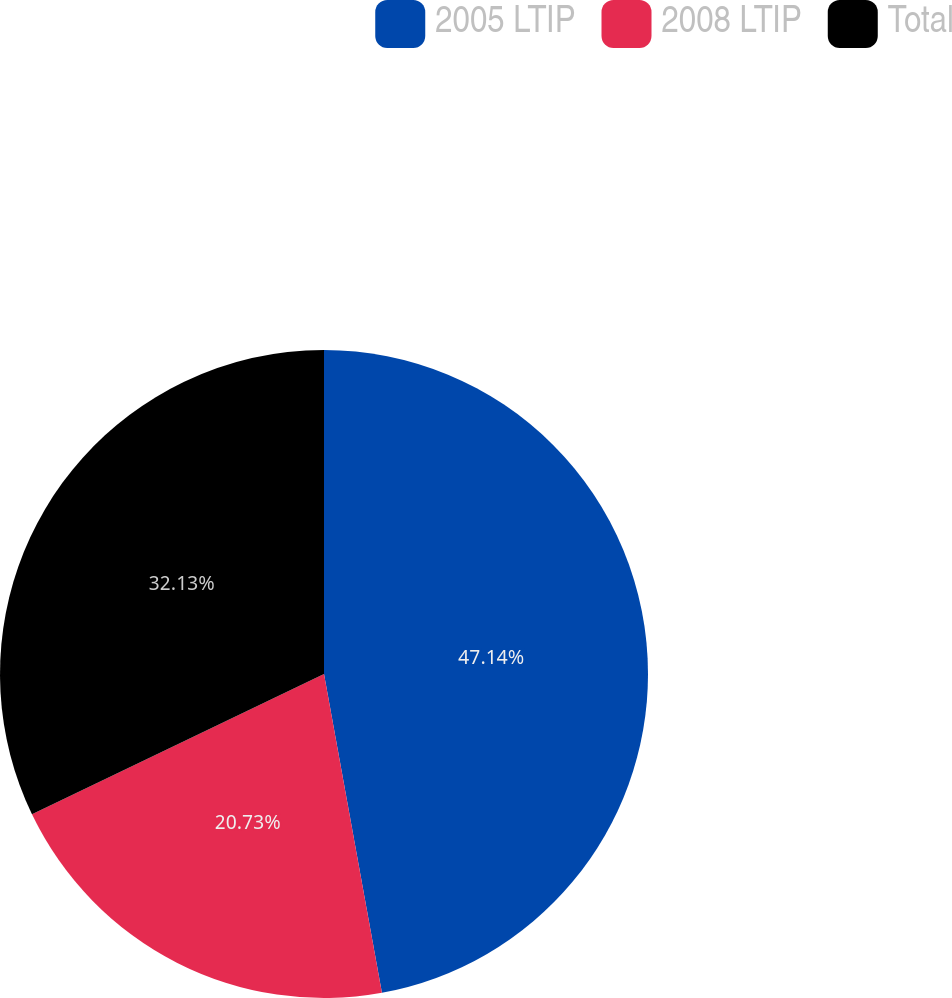<chart> <loc_0><loc_0><loc_500><loc_500><pie_chart><fcel>2005 LTIP<fcel>2008 LTIP<fcel>Total<nl><fcel>47.14%<fcel>20.73%<fcel>32.13%<nl></chart> 